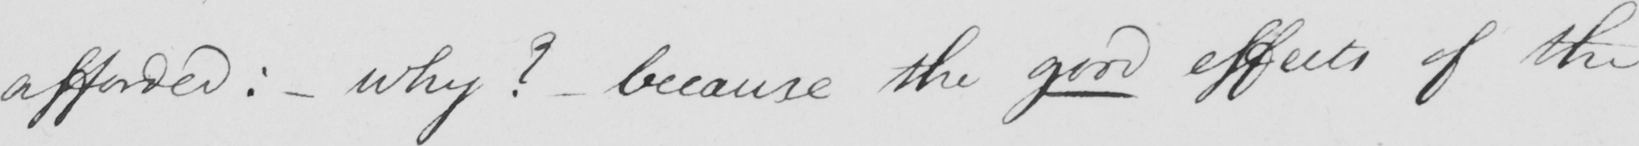Please provide the text content of this handwritten line. afforded :   _  why ?   _  because the good effects of the 